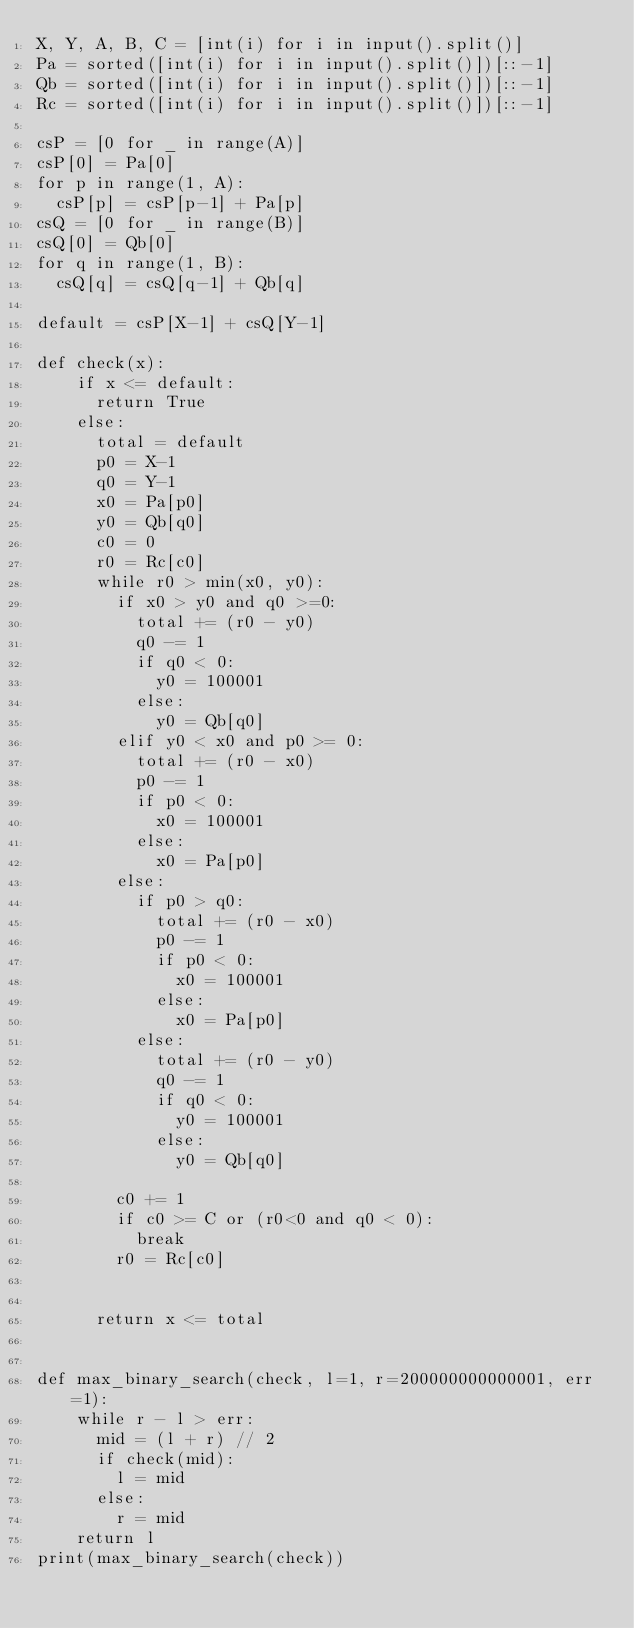Convert code to text. <code><loc_0><loc_0><loc_500><loc_500><_Python_>X, Y, A, B, C = [int(i) for i in input().split()]
Pa = sorted([int(i) for i in input().split()])[::-1]
Qb = sorted([int(i) for i in input().split()])[::-1]
Rc = sorted([int(i) for i in input().split()])[::-1]

csP = [0 for _ in range(A)]
csP[0] = Pa[0]
for p in range(1, A):
  csP[p] = csP[p-1] + Pa[p]
csQ = [0 for _ in range(B)]
csQ[0] = Qb[0]
for q in range(1, B):
  csQ[q] = csQ[q-1] + Qb[q]

default = csP[X-1] + csQ[Y-1]

def check(x):
    if x <= default:
      return True
    else:
      total = default
      p0 = X-1
      q0 = Y-1
      x0 = Pa[p0]
      y0 = Qb[q0]
      c0 = 0
      r0 = Rc[c0]
      while r0 > min(x0, y0):
        if x0 > y0 and q0 >=0:
          total += (r0 - y0)
          q0 -= 1
          if q0 < 0:
            y0 = 100001
          else:
            y0 = Qb[q0]
        elif y0 < x0 and p0 >= 0:
          total += (r0 - x0)
          p0 -= 1
          if p0 < 0:
            x0 = 100001
          else:
            x0 = Pa[p0]
        else:
          if p0 > q0:
            total += (r0 - x0)
            p0 -= 1
            if p0 < 0:
              x0 = 100001
            else:
              x0 = Pa[p0]
          else:
            total += (r0 - y0)
            q0 -= 1
            if q0 < 0:
              y0 = 100001
            else:
              y0 = Qb[q0]
                        
        c0 += 1
        if c0 >= C or (r0<0 and q0 < 0):
          break
        r0 = Rc[c0]
        
      
      return x <= total
    

def max_binary_search(check, l=1, r=200000000000001, err=1):
    while r - l > err:  
      mid = (l + r) // 2
      if check(mid):
        l = mid
      else:
        r = mid
    return l
print(max_binary_search(check))</code> 